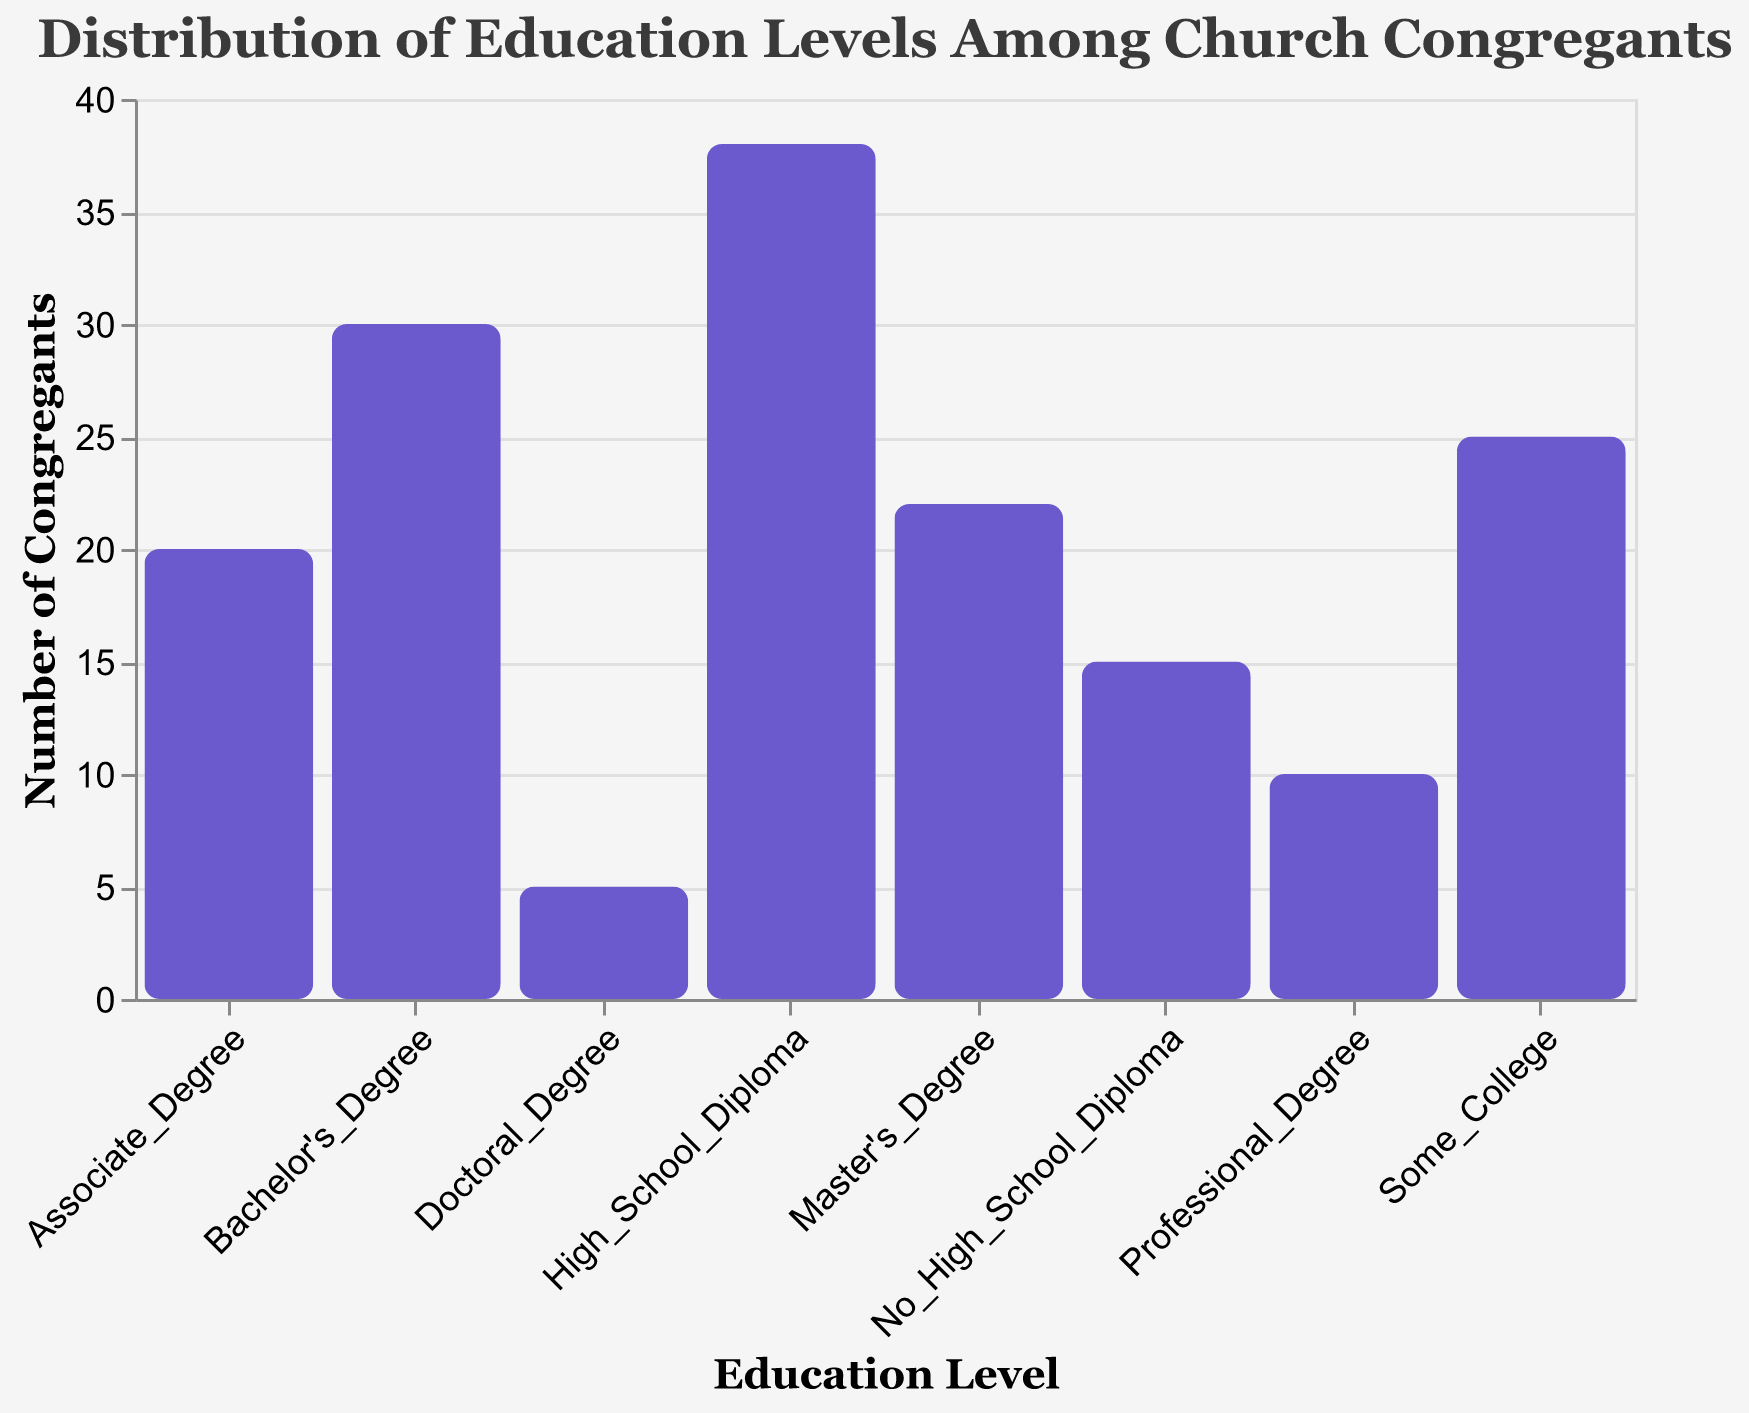What is the title of the plot? The title is displayed at the top of the plot and summarizes the content shown.
Answer: Distribution of Education Levels Among Church Congregants Which education level has the highest number of congregants? The tallest bar represents the highest value in the plot.
Answer: High School Diploma How many congregants have a Professional Degree? The tooltip or the top of the corresponding bar for Professional Degree indicates the number of congregants.
Answer: 10 What is the combined number of congregants with a Bachelor's Degree and a Master's Degree? Add the numbers of congregants for Bachelor's Degree and Master's Degree (30 + 22).
Answer: 52 How does the number of congregants with an Associate Degree compare to those with a Master's Degree? Compare the heights of the bars or tooltip values for both educational levels.
Answer: Fewer congregants have an Associate Degree than a Master's Degree (20 < 22) What is the overall trend in the number of congregants from lower to higher education levels? Observe the changes in bar height from left (No High School Diploma) to right (Professional Degree).
Answer: The number peaks at High School Diploma and generally decreases afterward Which two education levels have the closest number of congregants, and what are those numbers? Identify bars with similar heights and the smallest difference between their values.
Answer: Associate Degree (20) and Master's Degree (22) What fraction of the congregation has a Doctoral Degree? Divide the number of congregation members with a Doctoral Degree by the total count of congregants (5 / 165).
Answer: Approximately 0.03 or 3% What is the total number of congregants with some level of college education (Some College, Associate Degree, Bachelor's Degree, Master's Degree, Doctoral Degree, Professional Degree)? Add all the numbers for education levels from Some College up to Professional Degree.
Answer: 142 Which education level has significantly fewer congregants compared to a Bachelor's Degree? Look for an education level with a much shorter bar compared to Bachelor's Degree (30).
Answer: Doctoral Degree (5) 